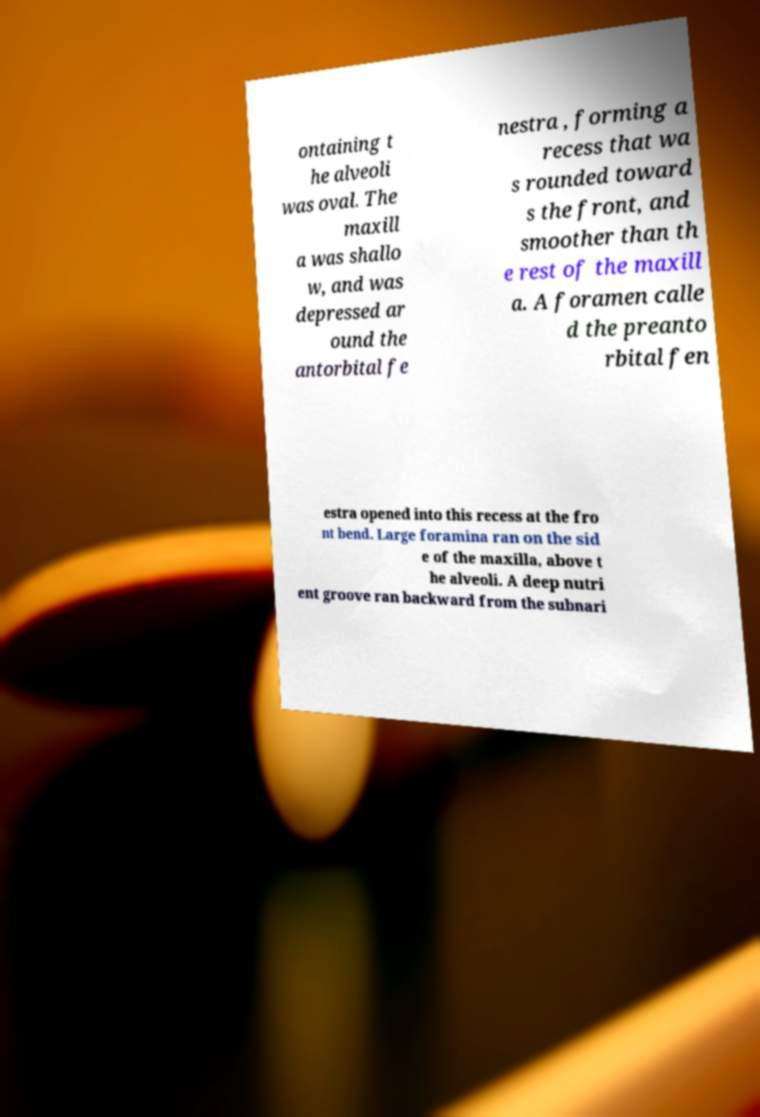Can you accurately transcribe the text from the provided image for me? ontaining t he alveoli was oval. The maxill a was shallo w, and was depressed ar ound the antorbital fe nestra , forming a recess that wa s rounded toward s the front, and smoother than th e rest of the maxill a. A foramen calle d the preanto rbital fen estra opened into this recess at the fro nt bend. Large foramina ran on the sid e of the maxilla, above t he alveoli. A deep nutri ent groove ran backward from the subnari 